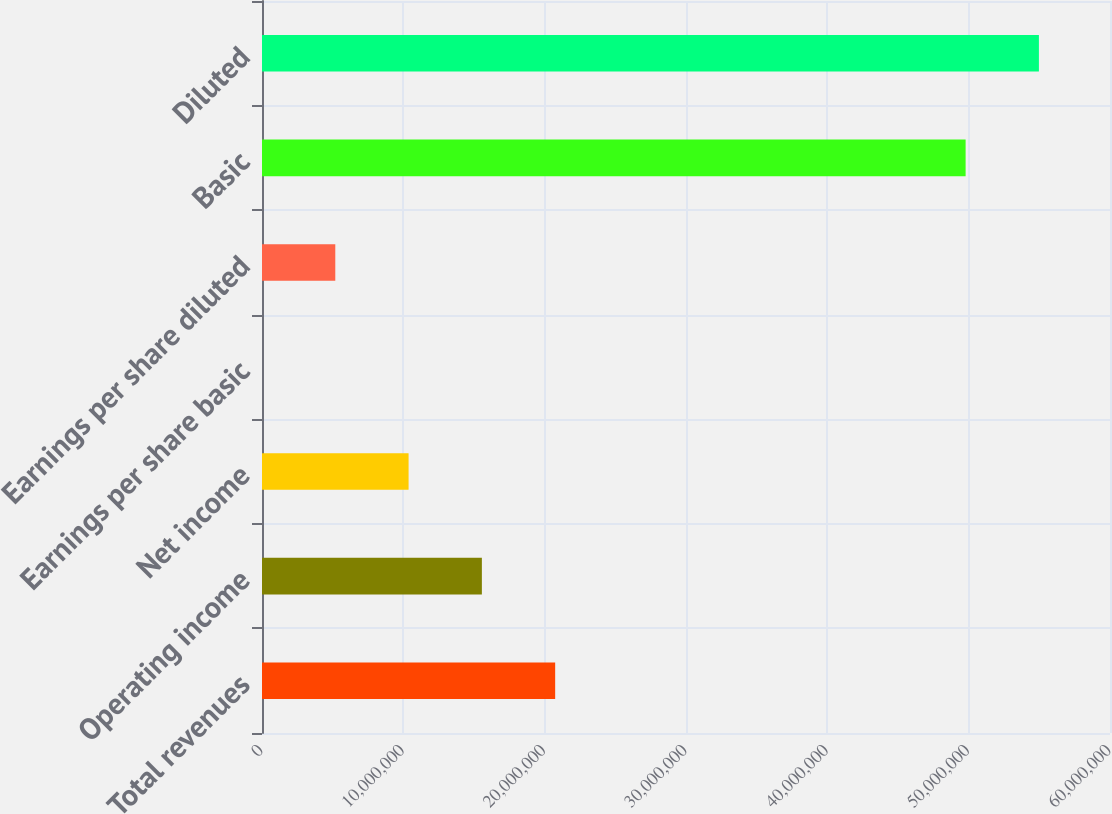Convert chart to OTSL. <chart><loc_0><loc_0><loc_500><loc_500><bar_chart><fcel>Total revenues<fcel>Operating income<fcel>Net income<fcel>Earnings per share basic<fcel>Earnings per share diluted<fcel>Basic<fcel>Diluted<nl><fcel>2.07429e+07<fcel>1.55572e+07<fcel>1.03715e+07<fcel>0.11<fcel>5.18573e+06<fcel>4.97842e+07<fcel>5.49699e+07<nl></chart> 